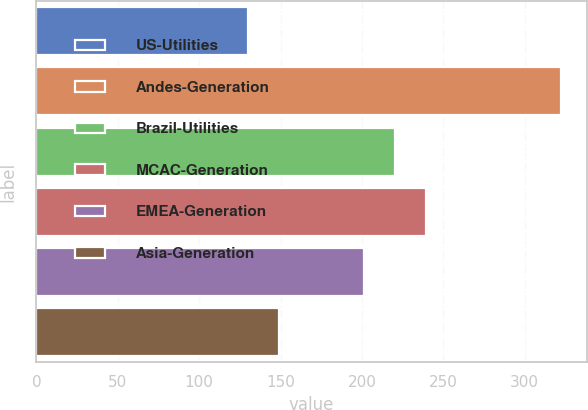Convert chart. <chart><loc_0><loc_0><loc_500><loc_500><bar_chart><fcel>US-Utilities<fcel>Andes-Generation<fcel>Brazil-Utilities<fcel>MCAC-Generation<fcel>EMEA-Generation<fcel>Asia-Generation<nl><fcel>130<fcel>322<fcel>220.2<fcel>239.4<fcel>201<fcel>149.2<nl></chart> 